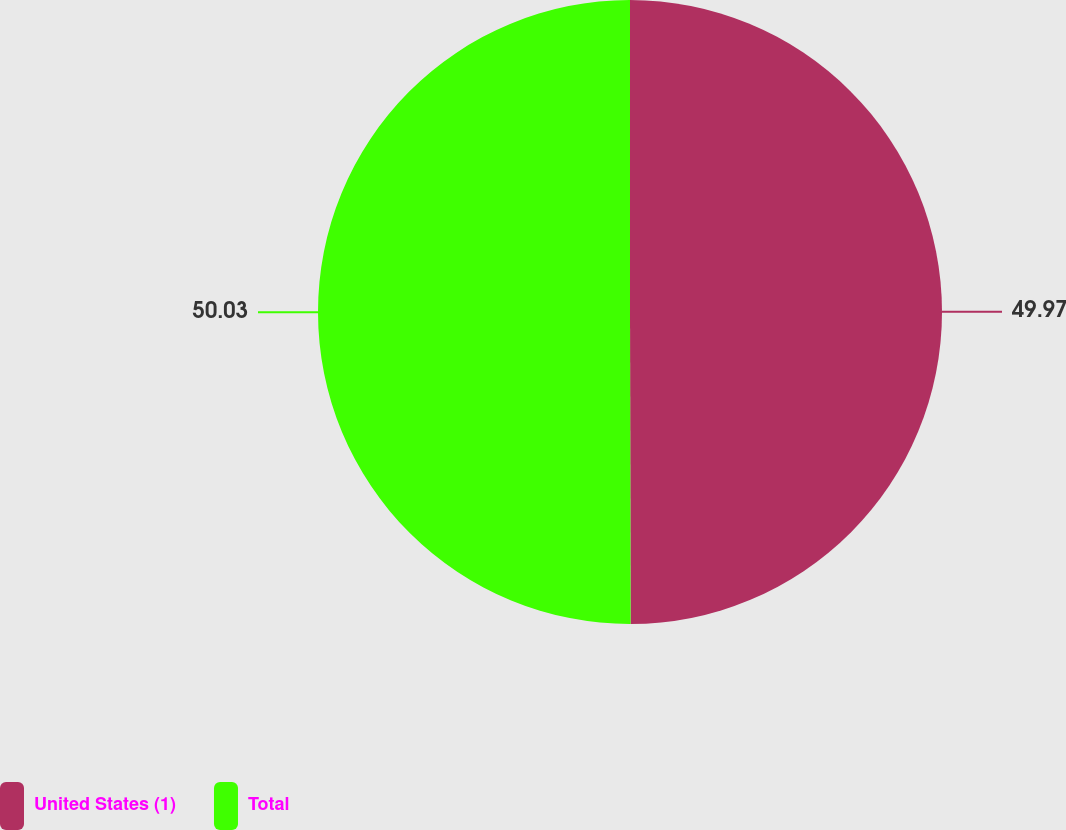Convert chart to OTSL. <chart><loc_0><loc_0><loc_500><loc_500><pie_chart><fcel>United States (1)<fcel>Total<nl><fcel>49.97%<fcel>50.03%<nl></chart> 